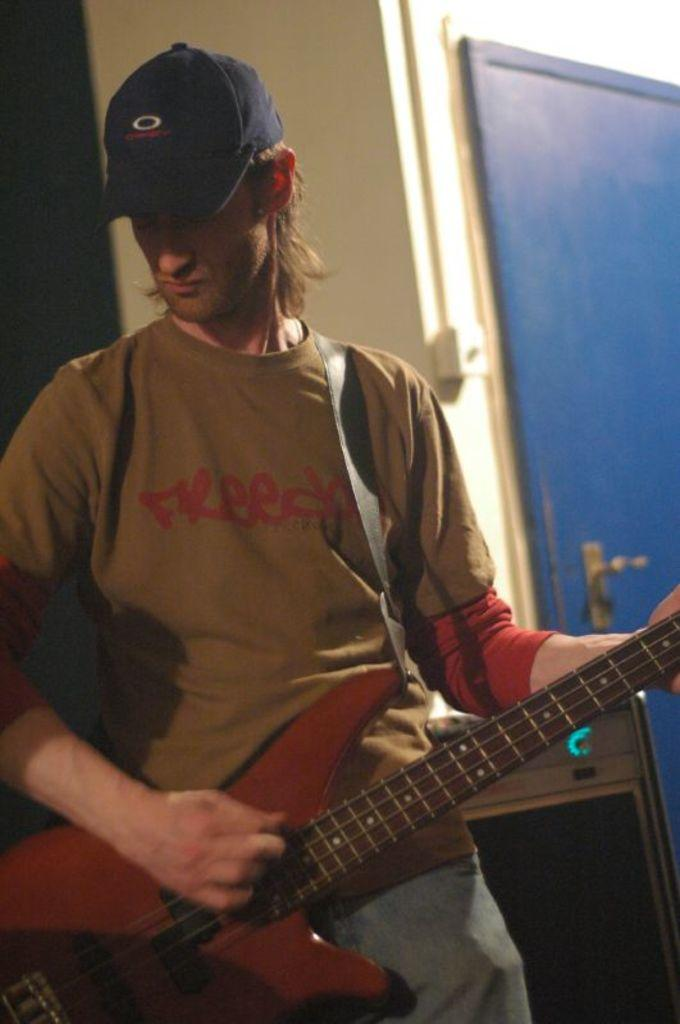What can be seen in the background of the image? There is a wall and a blue door in the background of the image. What is the man in the image doing? The man is playing a guitar. What is the man wearing on his head? The man is wearing a cap. What type of plant is growing near the blue door in the image? There is no plant visible near the blue door in the image. How many yams can be seen in the man's hands while he is playing the guitar? There are no yams present in the image; the man is playing a guitar and wearing a cap. 